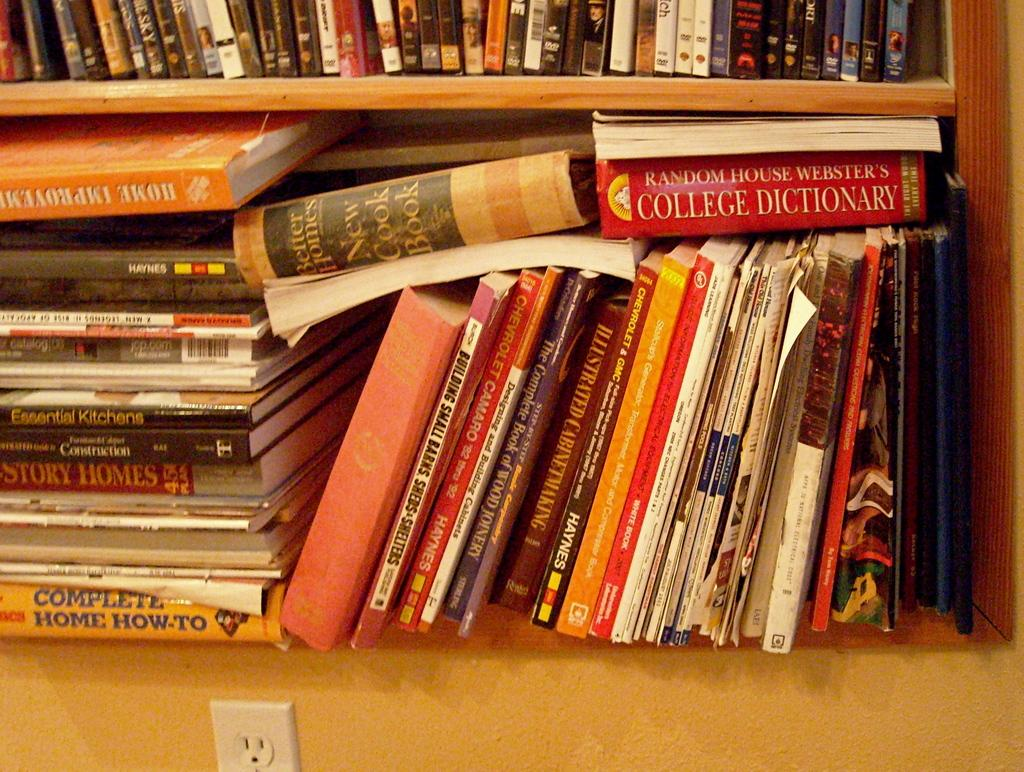<image>
Present a compact description of the photo's key features. several books piled on top of one another with one reading college dictionary. 